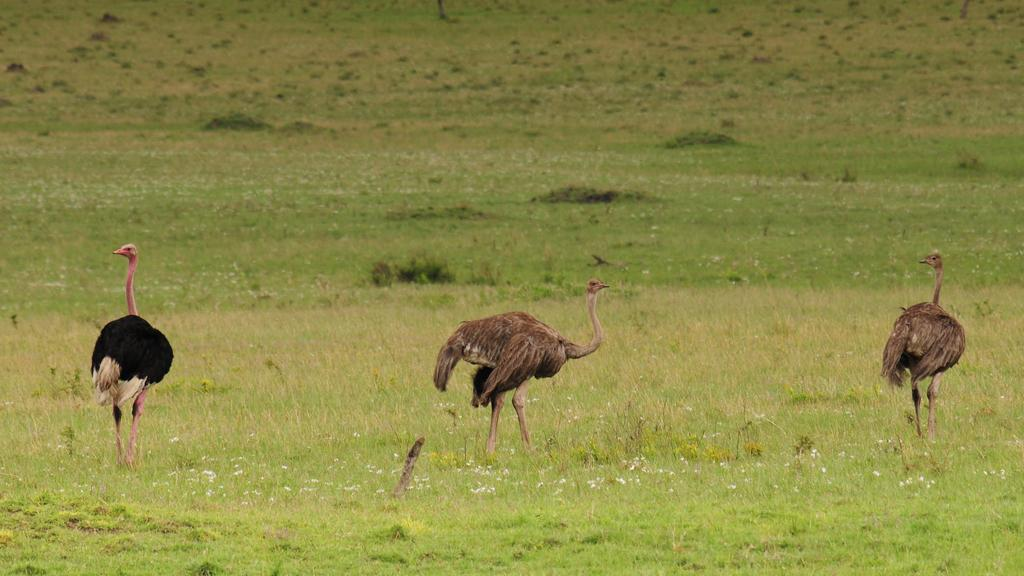Where was the image taken? The image was taken outdoors. What type of surface is visible in the image? There is a ground with grass in the image. How many ostriches are present in the image? There are three ostriches in the image. Where are the ostriches located in the image? The ostriches are on the ground. What type of club can be seen in the image? There is no club present in the image; it features three ostriches on a grassy ground. 